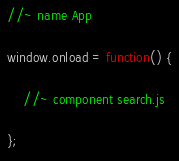<code> <loc_0><loc_0><loc_500><loc_500><_JavaScript_>//~ name App

window.onload = function() {

	//~ component search.js

};
</code> 